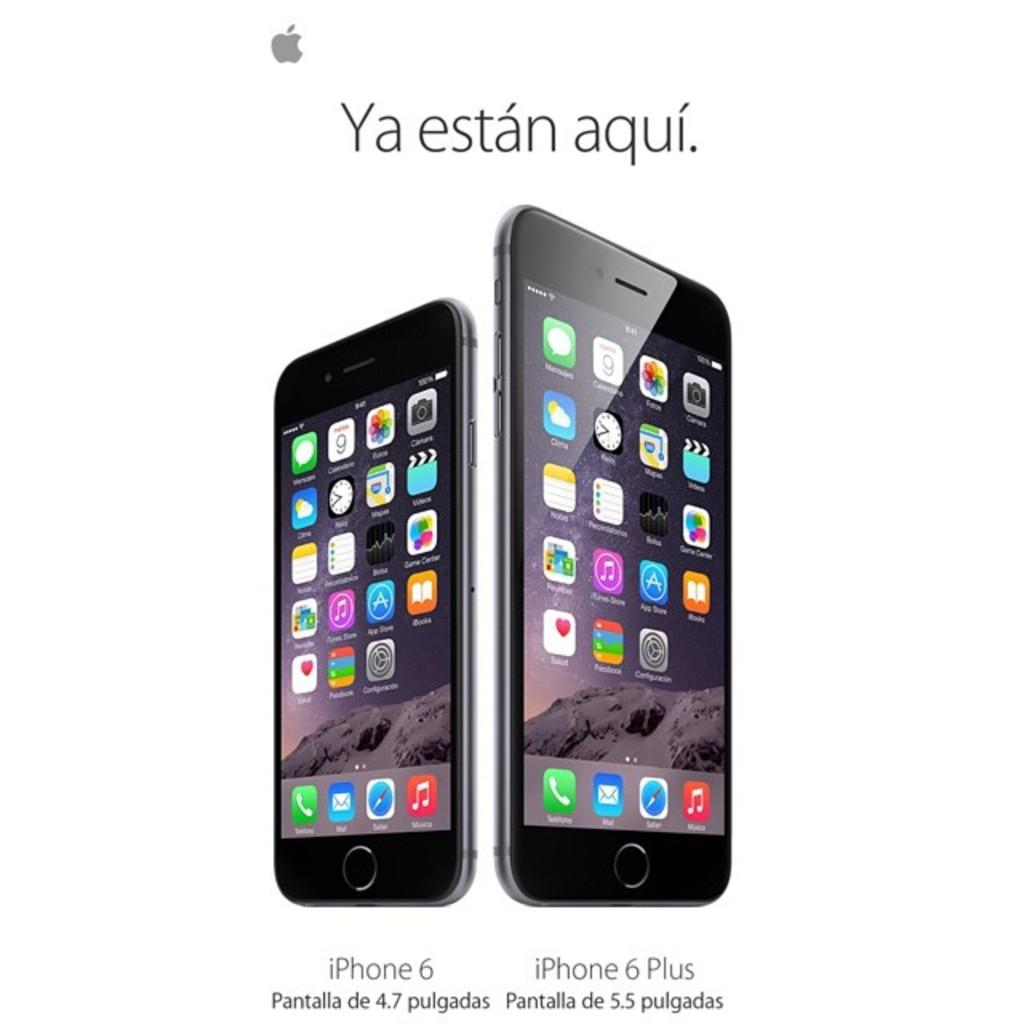<image>
Render a clear and concise summary of the photo. With both phone models shown side by side, you can see the iPhone 6 Plus is a lot bigger than the iPhone 6. 